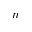Convert formula to latex. <formula><loc_0><loc_0><loc_500><loc_500>n</formula> 